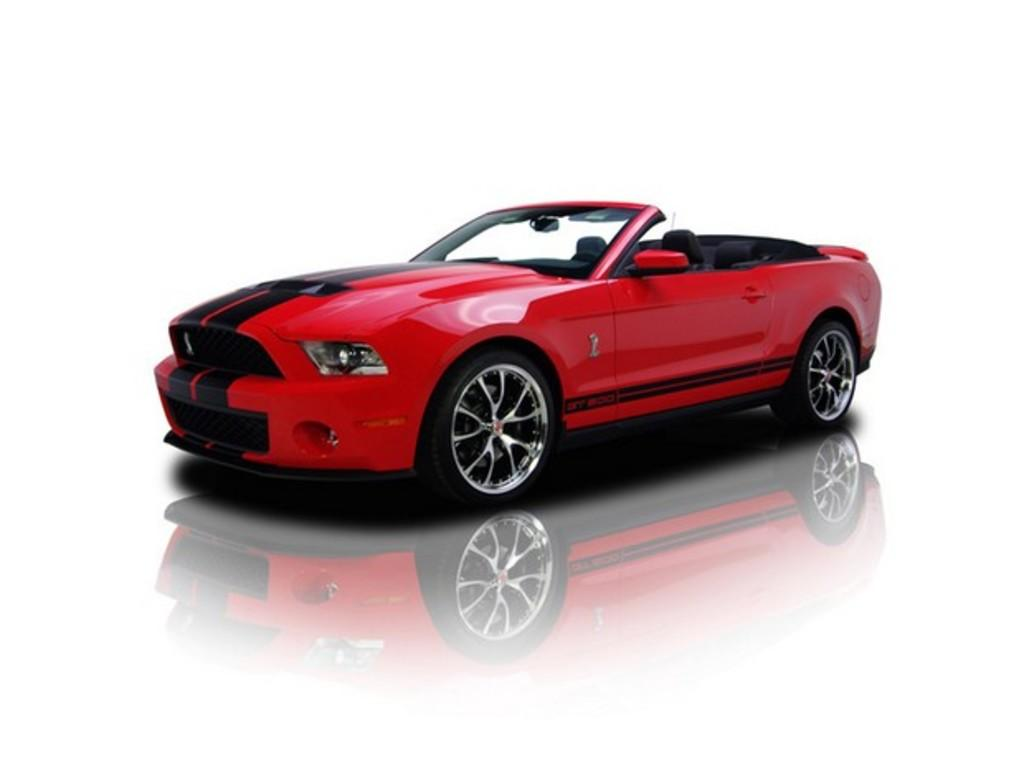What is the main subject of the image? The main subject of the image is a car. Can you describe the color of the car? The car is red and black in color. What type of church can be seen in the background of the image? There is no church present in the image; it only features a red and black car. 